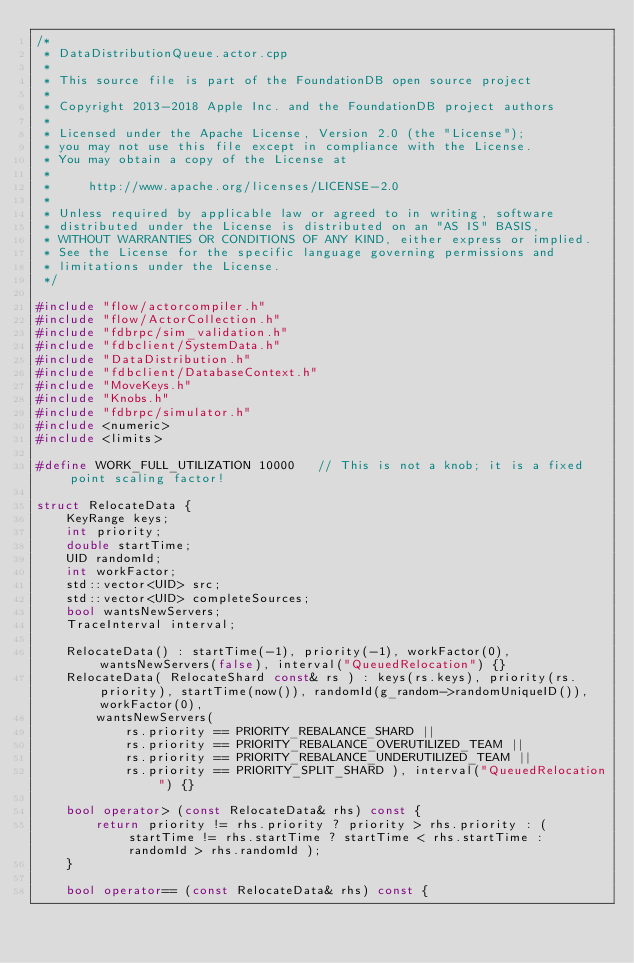Convert code to text. <code><loc_0><loc_0><loc_500><loc_500><_C++_>/*
 * DataDistributionQueue.actor.cpp
 *
 * This source file is part of the FoundationDB open source project
 *
 * Copyright 2013-2018 Apple Inc. and the FoundationDB project authors
 *
 * Licensed under the Apache License, Version 2.0 (the "License");
 * you may not use this file except in compliance with the License.
 * You may obtain a copy of the License at
 *
 *     http://www.apache.org/licenses/LICENSE-2.0
 *
 * Unless required by applicable law or agreed to in writing, software
 * distributed under the License is distributed on an "AS IS" BASIS,
 * WITHOUT WARRANTIES OR CONDITIONS OF ANY KIND, either express or implied.
 * See the License for the specific language governing permissions and
 * limitations under the License.
 */

#include "flow/actorcompiler.h"
#include "flow/ActorCollection.h"
#include "fdbrpc/sim_validation.h"
#include "fdbclient/SystemData.h"
#include "DataDistribution.h"
#include "fdbclient/DatabaseContext.h"
#include "MoveKeys.h"
#include "Knobs.h"
#include "fdbrpc/simulator.h"
#include <numeric>
#include <limits>

#define WORK_FULL_UTILIZATION 10000   // This is not a knob; it is a fixed point scaling factor!

struct RelocateData {
	KeyRange keys;
	int priority;
	double startTime;
	UID randomId;
	int workFactor;
	std::vector<UID> src;
	std::vector<UID> completeSources;
	bool wantsNewServers;
	TraceInterval interval;

	RelocateData() : startTime(-1), priority(-1), workFactor(0), wantsNewServers(false), interval("QueuedRelocation") {}
	RelocateData( RelocateShard const& rs ) : keys(rs.keys), priority(rs.priority), startTime(now()), randomId(g_random->randomUniqueID()), workFactor(0),
		wantsNewServers(
			rs.priority == PRIORITY_REBALANCE_SHARD ||
			rs.priority == PRIORITY_REBALANCE_OVERUTILIZED_TEAM ||
			rs.priority == PRIORITY_REBALANCE_UNDERUTILIZED_TEAM ||
			rs.priority == PRIORITY_SPLIT_SHARD ), interval("QueuedRelocation") {}

	bool operator> (const RelocateData& rhs) const {
		return priority != rhs.priority ? priority > rhs.priority : ( startTime != rhs.startTime ? startTime < rhs.startTime : randomId > rhs.randomId );
	}

	bool operator== (const RelocateData& rhs) const {</code> 